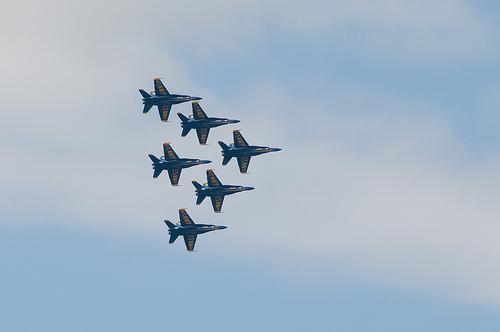How many different models of plane are shown?
Give a very brief answer. 1. 